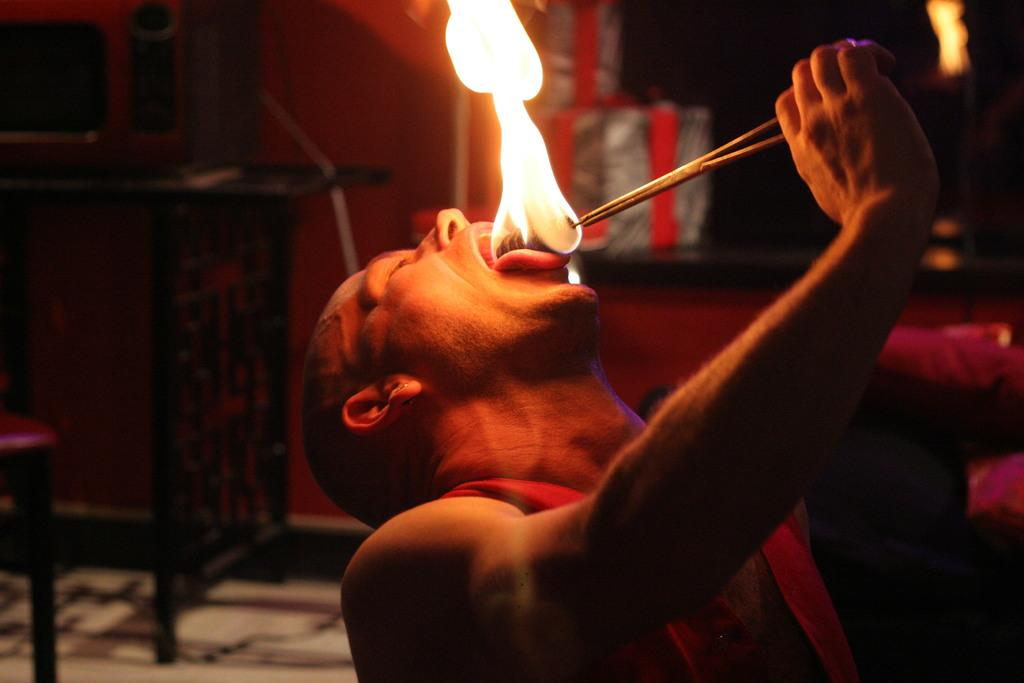Who is the main subject in the image? There is a man in the image. What is the man doing in the image? The man has fire on his tongue. What furniture is present on the left side of the image? There is a chair and table on the left side of the image. Can you describe the background of the image? The background of the image is blurred. What month is the representative attending the cable conference in the image? There is no representative or cable conference present in the image. 